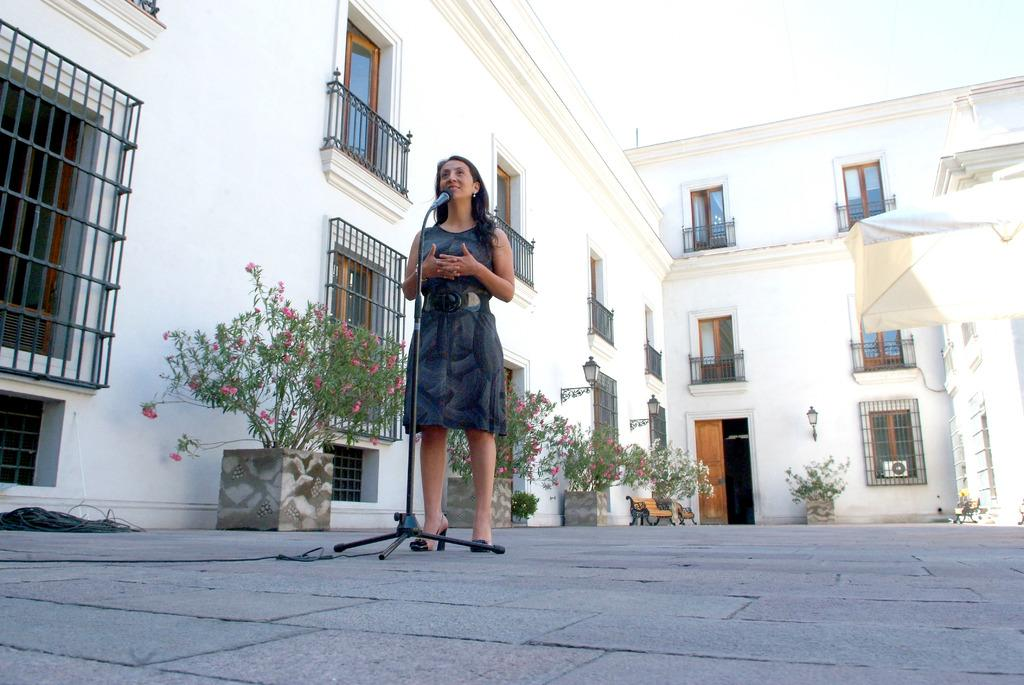What is the woman doing in the image? The woman is standing in front of a mic. What can be seen in the background of the image? There are plants, benches, and buildings in the background of the image. What features do the buildings have? The buildings have doors and railings. What type of toy can be seen on the ground near the woman? There is no toy present in the image. What is the income of the woman in the image? The income of the woman cannot be determined from the image. 